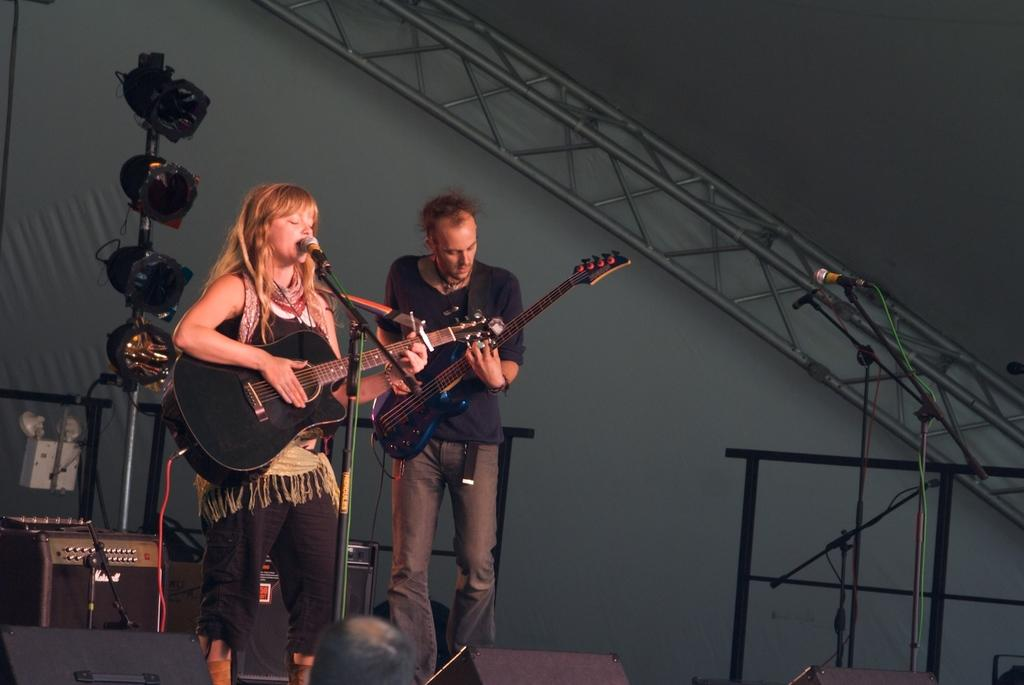How many people are in the image? There are two people in the image, a woman and a man. What are the woman and the man holding in the image? Both the woman and the man are holding guitars. What is in front of the woman? There is a microphone in front of the woman. What can be seen in the background of the image? There is a wall, metal rods, and lights in the background of the image. What type of record can be seen on the wall in the image? There is no record present on the wall in the image. Can you tell me how many rats are visible in the image? There are no rats visible in the image. What stage of development is the project in, as seen in the image? The image does not depict a project or any development stages. 